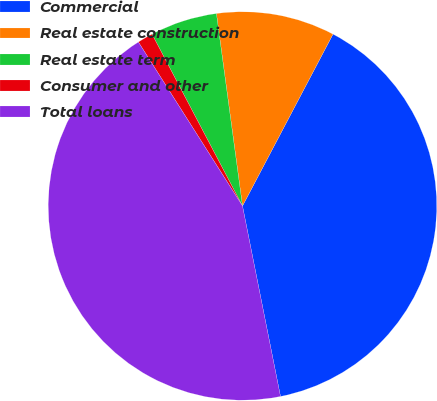Convert chart. <chart><loc_0><loc_0><loc_500><loc_500><pie_chart><fcel>Commercial<fcel>Real estate construction<fcel>Real estate term<fcel>Consumer and other<fcel>Total loans<nl><fcel>39.15%<fcel>9.86%<fcel>5.57%<fcel>1.29%<fcel>44.13%<nl></chart> 